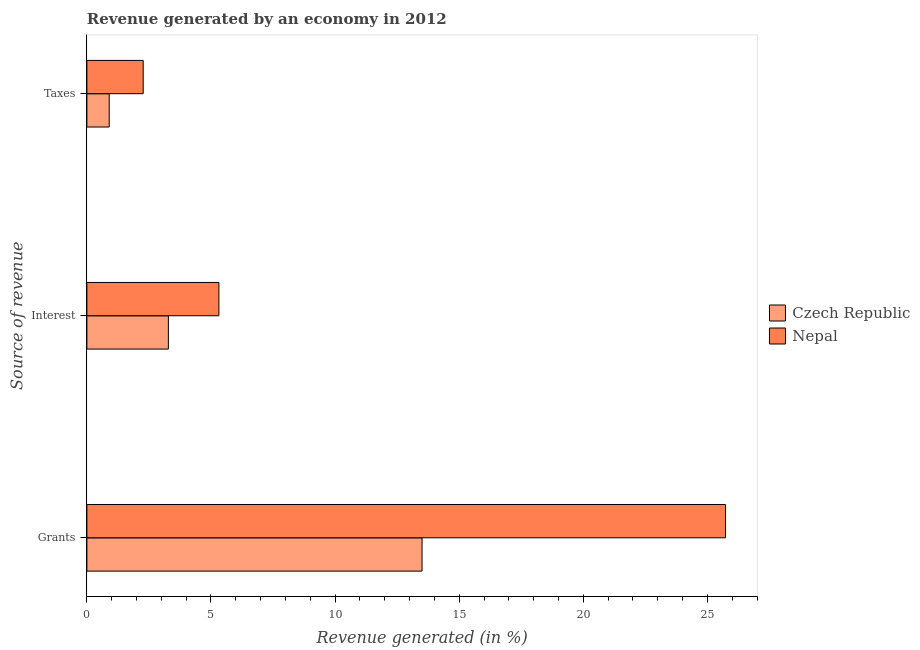How many different coloured bars are there?
Offer a terse response. 2. Are the number of bars per tick equal to the number of legend labels?
Your answer should be compact. Yes. Are the number of bars on each tick of the Y-axis equal?
Give a very brief answer. Yes. How many bars are there on the 3rd tick from the bottom?
Provide a short and direct response. 2. What is the label of the 2nd group of bars from the top?
Provide a succinct answer. Interest. What is the percentage of revenue generated by interest in Nepal?
Offer a terse response. 5.32. Across all countries, what is the maximum percentage of revenue generated by grants?
Keep it short and to the point. 25.73. Across all countries, what is the minimum percentage of revenue generated by taxes?
Offer a very short reply. 0.9. In which country was the percentage of revenue generated by grants maximum?
Ensure brevity in your answer.  Nepal. In which country was the percentage of revenue generated by taxes minimum?
Keep it short and to the point. Czech Republic. What is the total percentage of revenue generated by grants in the graph?
Ensure brevity in your answer.  39.23. What is the difference between the percentage of revenue generated by grants in Czech Republic and that in Nepal?
Give a very brief answer. -12.23. What is the difference between the percentage of revenue generated by grants in Czech Republic and the percentage of revenue generated by interest in Nepal?
Ensure brevity in your answer.  8.18. What is the average percentage of revenue generated by taxes per country?
Your response must be concise. 1.58. What is the difference between the percentage of revenue generated by interest and percentage of revenue generated by taxes in Nepal?
Your answer should be very brief. 3.05. In how many countries, is the percentage of revenue generated by taxes greater than 12 %?
Your answer should be compact. 0. What is the ratio of the percentage of revenue generated by taxes in Czech Republic to that in Nepal?
Give a very brief answer. 0.4. Is the percentage of revenue generated by grants in Nepal less than that in Czech Republic?
Your answer should be compact. No. Is the difference between the percentage of revenue generated by interest in Nepal and Czech Republic greater than the difference between the percentage of revenue generated by grants in Nepal and Czech Republic?
Ensure brevity in your answer.  No. What is the difference between the highest and the second highest percentage of revenue generated by grants?
Your answer should be very brief. 12.23. What is the difference between the highest and the lowest percentage of revenue generated by interest?
Ensure brevity in your answer.  2.04. What does the 2nd bar from the top in Grants represents?
Your response must be concise. Czech Republic. What does the 2nd bar from the bottom in Grants represents?
Keep it short and to the point. Nepal. Is it the case that in every country, the sum of the percentage of revenue generated by grants and percentage of revenue generated by interest is greater than the percentage of revenue generated by taxes?
Give a very brief answer. Yes. Are all the bars in the graph horizontal?
Keep it short and to the point. Yes. How many countries are there in the graph?
Provide a succinct answer. 2. What is the difference between two consecutive major ticks on the X-axis?
Offer a very short reply. 5. Does the graph contain any zero values?
Offer a very short reply. No. What is the title of the graph?
Your answer should be very brief. Revenue generated by an economy in 2012. What is the label or title of the X-axis?
Your answer should be compact. Revenue generated (in %). What is the label or title of the Y-axis?
Your response must be concise. Source of revenue. What is the Revenue generated (in %) of Czech Republic in Grants?
Offer a very short reply. 13.5. What is the Revenue generated (in %) in Nepal in Grants?
Offer a terse response. 25.73. What is the Revenue generated (in %) in Czech Republic in Interest?
Keep it short and to the point. 3.28. What is the Revenue generated (in %) of Nepal in Interest?
Keep it short and to the point. 5.32. What is the Revenue generated (in %) of Czech Republic in Taxes?
Your answer should be compact. 0.9. What is the Revenue generated (in %) of Nepal in Taxes?
Keep it short and to the point. 2.27. Across all Source of revenue, what is the maximum Revenue generated (in %) in Czech Republic?
Provide a short and direct response. 13.5. Across all Source of revenue, what is the maximum Revenue generated (in %) of Nepal?
Provide a short and direct response. 25.73. Across all Source of revenue, what is the minimum Revenue generated (in %) of Czech Republic?
Your response must be concise. 0.9. Across all Source of revenue, what is the minimum Revenue generated (in %) of Nepal?
Offer a terse response. 2.27. What is the total Revenue generated (in %) in Czech Republic in the graph?
Your response must be concise. 17.69. What is the total Revenue generated (in %) in Nepal in the graph?
Your answer should be compact. 33.32. What is the difference between the Revenue generated (in %) in Czech Republic in Grants and that in Interest?
Provide a succinct answer. 10.22. What is the difference between the Revenue generated (in %) in Nepal in Grants and that in Interest?
Offer a terse response. 20.41. What is the difference between the Revenue generated (in %) of Czech Republic in Grants and that in Taxes?
Offer a terse response. 12.6. What is the difference between the Revenue generated (in %) of Nepal in Grants and that in Taxes?
Keep it short and to the point. 23.46. What is the difference between the Revenue generated (in %) of Czech Republic in Interest and that in Taxes?
Offer a terse response. 2.38. What is the difference between the Revenue generated (in %) of Nepal in Interest and that in Taxes?
Your answer should be very brief. 3.05. What is the difference between the Revenue generated (in %) of Czech Republic in Grants and the Revenue generated (in %) of Nepal in Interest?
Keep it short and to the point. 8.18. What is the difference between the Revenue generated (in %) in Czech Republic in Grants and the Revenue generated (in %) in Nepal in Taxes?
Your answer should be very brief. 11.23. What is the difference between the Revenue generated (in %) in Czech Republic in Interest and the Revenue generated (in %) in Nepal in Taxes?
Your response must be concise. 1.01. What is the average Revenue generated (in %) in Czech Republic per Source of revenue?
Make the answer very short. 5.89. What is the average Revenue generated (in %) of Nepal per Source of revenue?
Give a very brief answer. 11.11. What is the difference between the Revenue generated (in %) in Czech Republic and Revenue generated (in %) in Nepal in Grants?
Make the answer very short. -12.23. What is the difference between the Revenue generated (in %) in Czech Republic and Revenue generated (in %) in Nepal in Interest?
Give a very brief answer. -2.04. What is the difference between the Revenue generated (in %) in Czech Republic and Revenue generated (in %) in Nepal in Taxes?
Offer a very short reply. -1.37. What is the ratio of the Revenue generated (in %) of Czech Republic in Grants to that in Interest?
Your answer should be very brief. 4.11. What is the ratio of the Revenue generated (in %) in Nepal in Grants to that in Interest?
Make the answer very short. 4.84. What is the ratio of the Revenue generated (in %) of Czech Republic in Grants to that in Taxes?
Ensure brevity in your answer.  15.01. What is the ratio of the Revenue generated (in %) of Nepal in Grants to that in Taxes?
Give a very brief answer. 11.34. What is the ratio of the Revenue generated (in %) of Czech Republic in Interest to that in Taxes?
Make the answer very short. 3.65. What is the ratio of the Revenue generated (in %) in Nepal in Interest to that in Taxes?
Keep it short and to the point. 2.34. What is the difference between the highest and the second highest Revenue generated (in %) of Czech Republic?
Make the answer very short. 10.22. What is the difference between the highest and the second highest Revenue generated (in %) of Nepal?
Make the answer very short. 20.41. What is the difference between the highest and the lowest Revenue generated (in %) of Czech Republic?
Make the answer very short. 12.6. What is the difference between the highest and the lowest Revenue generated (in %) in Nepal?
Your response must be concise. 23.46. 